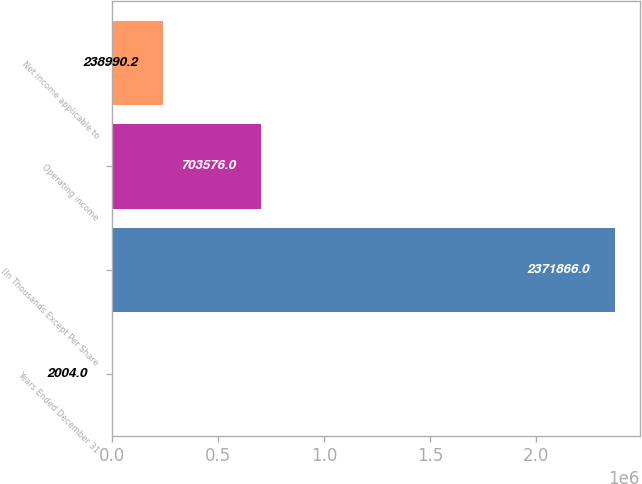Convert chart. <chart><loc_0><loc_0><loc_500><loc_500><bar_chart><fcel>Years Ended December 31<fcel>(In Thousands Except Per Share<fcel>Operating income<fcel>Net income applicable to<nl><fcel>2004<fcel>2.37187e+06<fcel>703576<fcel>238990<nl></chart> 